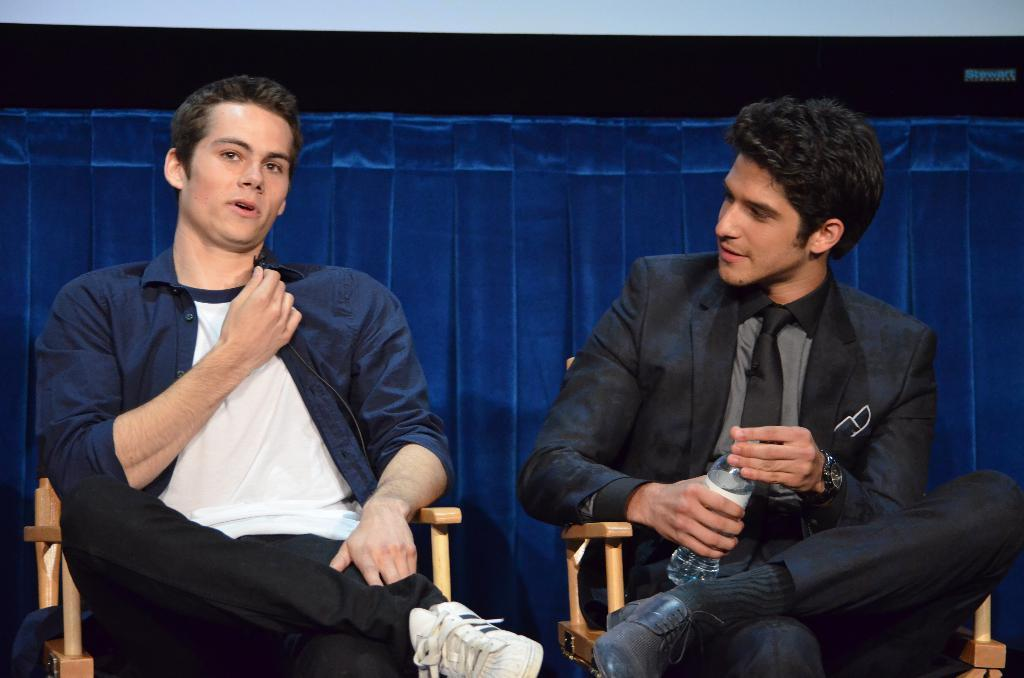How many people are in the image? There are two persons in the image. What are the persons doing in the image? The persons are sitting on chairs. What is one person holding in the image? One person is holding a bottle. What can be seen in the background of the image? There is a blue color curtain in the background. What type of home can be seen in the image? There is no home visible in the image; it only shows two persons sitting on chairs with a blue color curtain in the background. How many friends are present in the image? The number of friends cannot be determined from the image, as it only shows two persons sitting on chairs. 